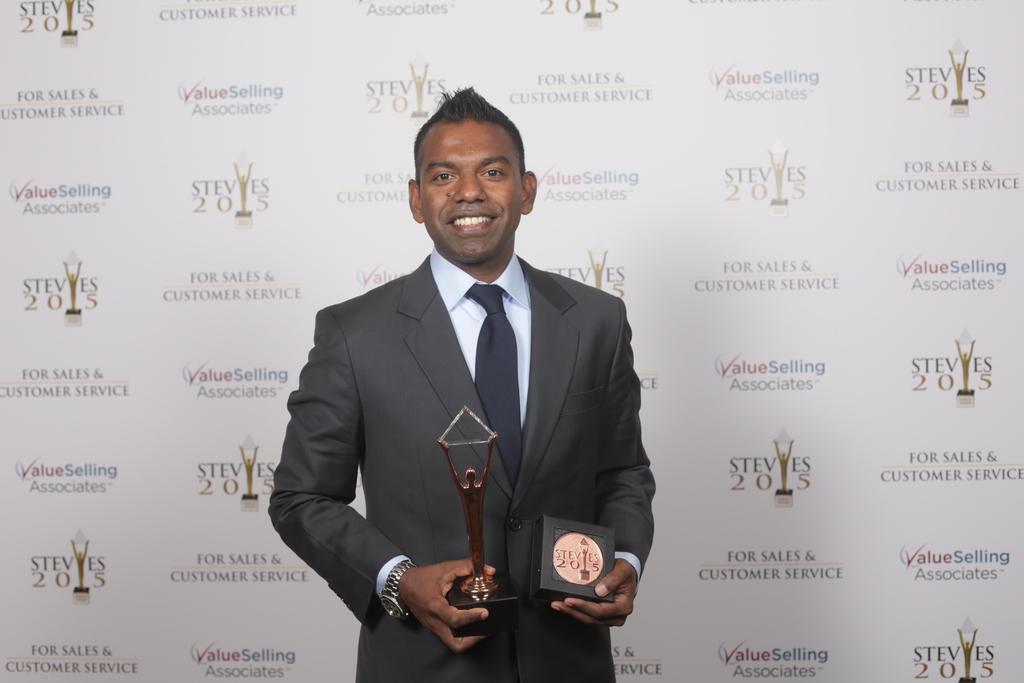In one or two sentences, can you explain what this image depicts? In this picture we can see a person standing and holding memento, behind we can see a board. 